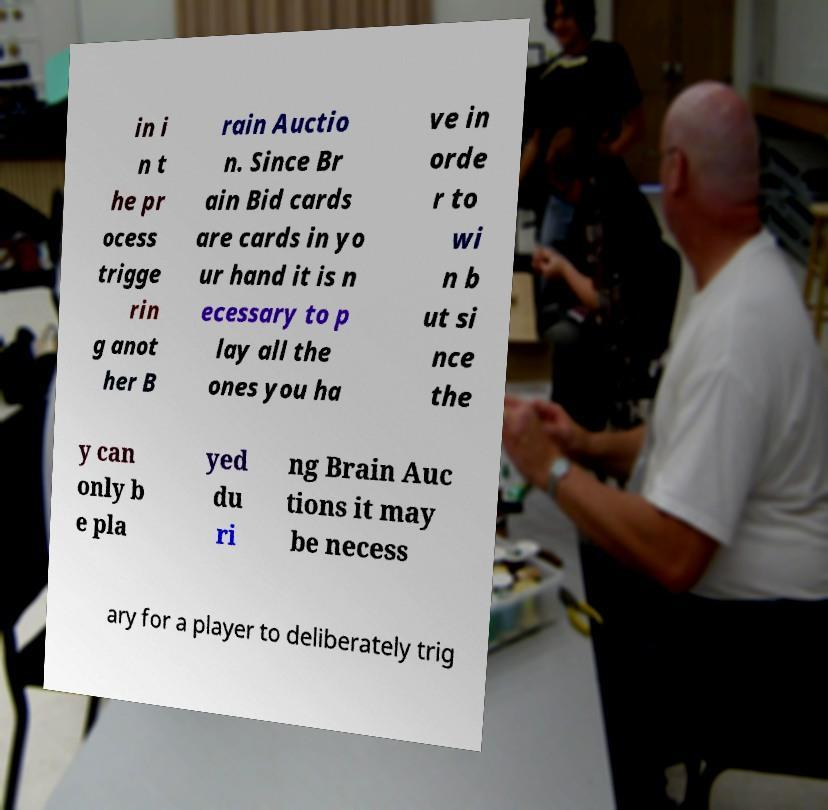Can you accurately transcribe the text from the provided image for me? in i n t he pr ocess trigge rin g anot her B rain Auctio n. Since Br ain Bid cards are cards in yo ur hand it is n ecessary to p lay all the ones you ha ve in orde r to wi n b ut si nce the y can only b e pla yed du ri ng Brain Auc tions it may be necess ary for a player to deliberately trig 